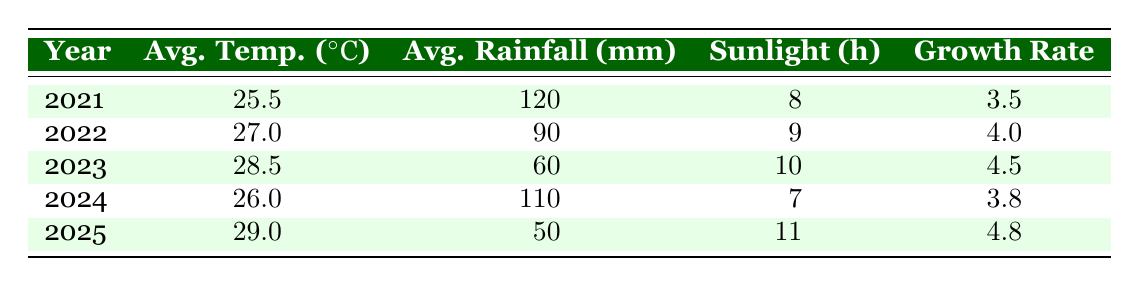What was the average temperature in 2022? In the table, the row for the year 2022 shows an average temperature of 27.0 degrees Celsius.
Answer: 27.0 Which year had the highest growth rate? The table indicates that the growth rate peaked at 4.8 in the year 2025.
Answer: 2025 What is the difference between the average rainfall in 2021 and 2023? In 2021, the average rainfall was 120 mm, while in 2023 it was 60 mm. The difference is calculated as 120 - 60 = 60 mm.
Answer: 60 mm Is the average temperature in 2024 higher than in 2021? The average temperature in 2024 is 26.0 degrees Celsius, which is lower than the 25.5 degrees in 2021. Therefore, the statement is false.
Answer: No What is the average growth rate over the five years recorded? To find the average growth rate, sum the growth rates: (3.5 + 4.0 + 4.5 + 3.8 + 4.8) = 20.6. Then divide by 5 to get 20.6 / 5 = 4.12.
Answer: 4.12 Which year had the least sunlight hours? The year with the least sunlight hours is 2024, with only 7 hours recorded.
Answer: 2024 What is the total average rainfall across all the years? The total average rainfall is calculated by summing the rainfall for each year: 120 + 90 + 60 + 110 + 50 = 430 mm.
Answer: 430 mm Was the average growth rate in 2023 greater than in 2022? In the table, the growth rate for 2023 is 4.5, which is greater than the 4.0 recorded in 2022, making the statement true.
Answer: Yes How much did the average temperature increase from 2021 to 2025? The average temperature in 2021 was 25.5 degrees Celsius and in 2025 it was 29.0 degrees Celsius. The increase is calculated as 29.0 - 25.5 = 3.5 degrees.
Answer: 3.5 degrees 